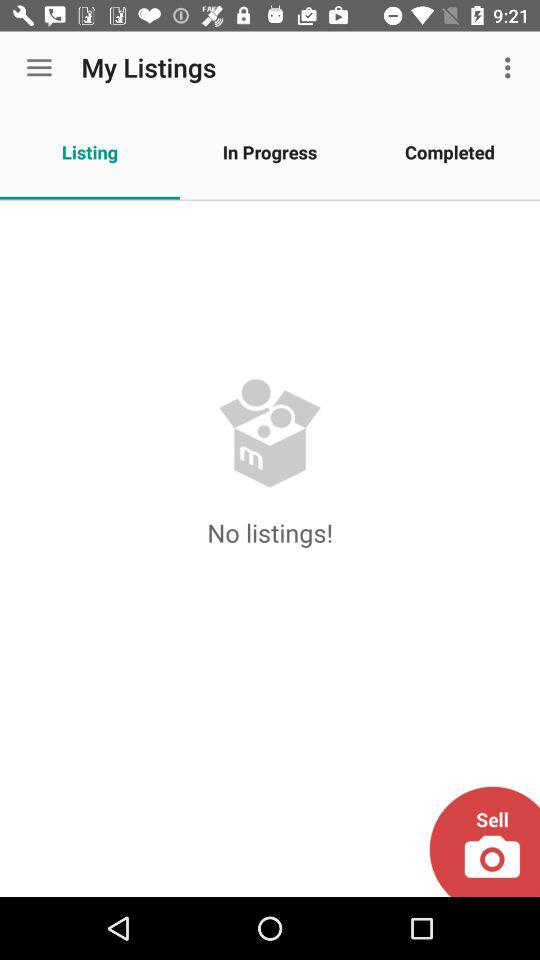Which items are in progress?
When the provided information is insufficient, respond with <no answer>. <no answer> 